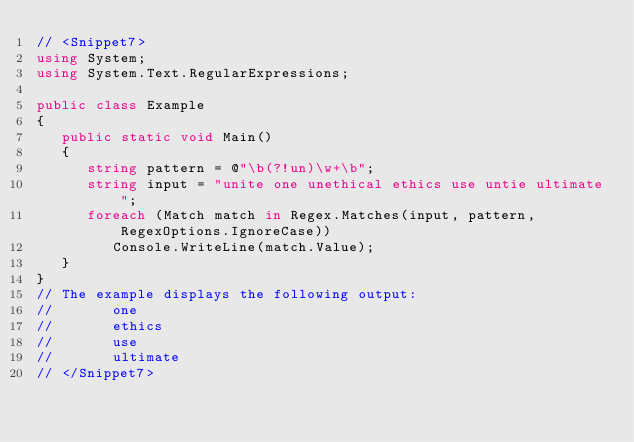Convert code to text. <code><loc_0><loc_0><loc_500><loc_500><_C#_>// <Snippet7>
using System;
using System.Text.RegularExpressions;

public class Example
{
   public static void Main()
   {
      string pattern = @"\b(?!un)\w+\b";
      string input = "unite one unethical ethics use untie ultimate";
      foreach (Match match in Regex.Matches(input, pattern, RegexOptions.IgnoreCase))
         Console.WriteLine(match.Value);
   }
}
// The example displays the following output:
//       one
//       ethics
//       use
//       ultimate
// </Snippet7>
</code> 